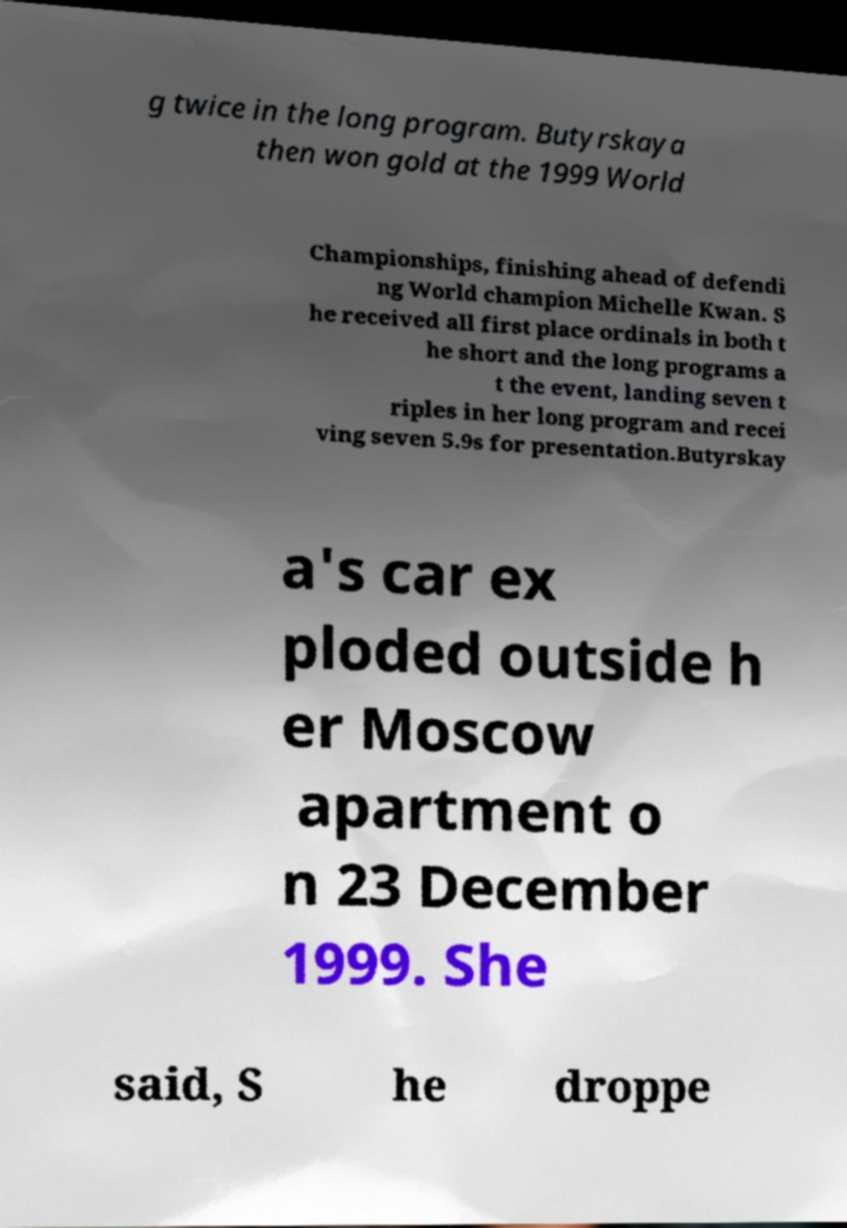What messages or text are displayed in this image? I need them in a readable, typed format. g twice in the long program. Butyrskaya then won gold at the 1999 World Championships, finishing ahead of defendi ng World champion Michelle Kwan. S he received all first place ordinals in both t he short and the long programs a t the event, landing seven t riples in her long program and recei ving seven 5.9s for presentation.Butyrskay a's car ex ploded outside h er Moscow apartment o n 23 December 1999. She said, S he droppe 